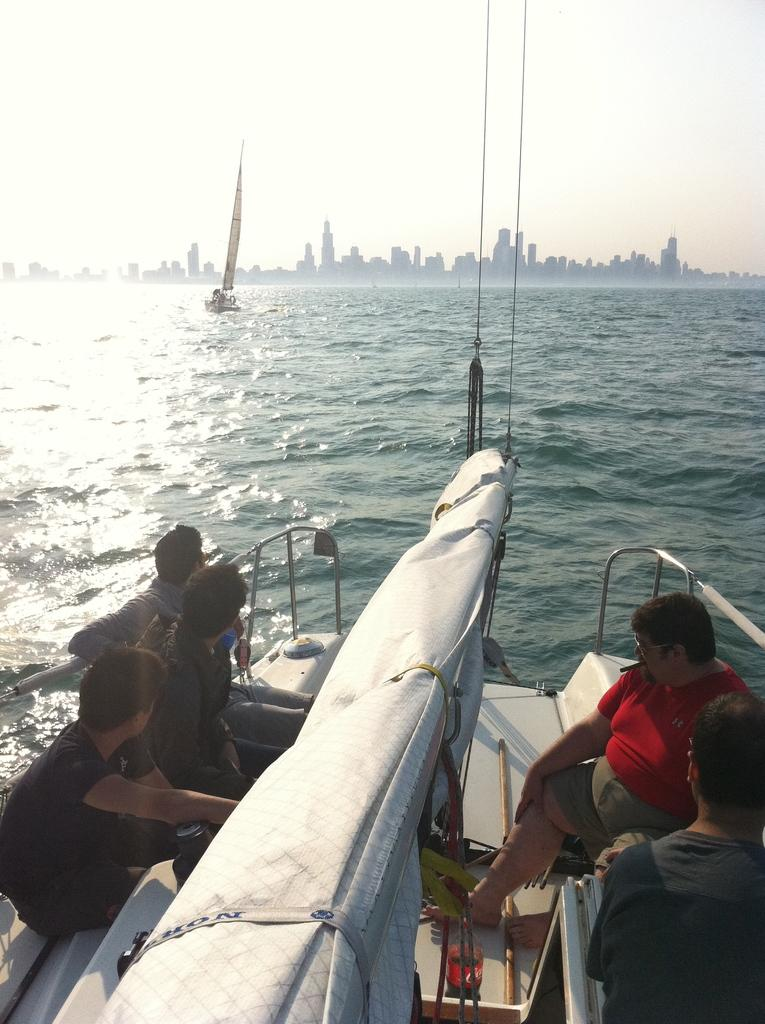What type of vehicles are in the water in the image? There are boats in the water in the image. Who is in the boats? There are people seated in the boats. What can be seen in the background of the image? There are buildings visible in the image. How would you describe the weather based on the image? The sky is cloudy in the image. How many tickets are needed to ride the salt in the image? There is no salt or tickets present in the image; it features boats in the water with people seated in them. 